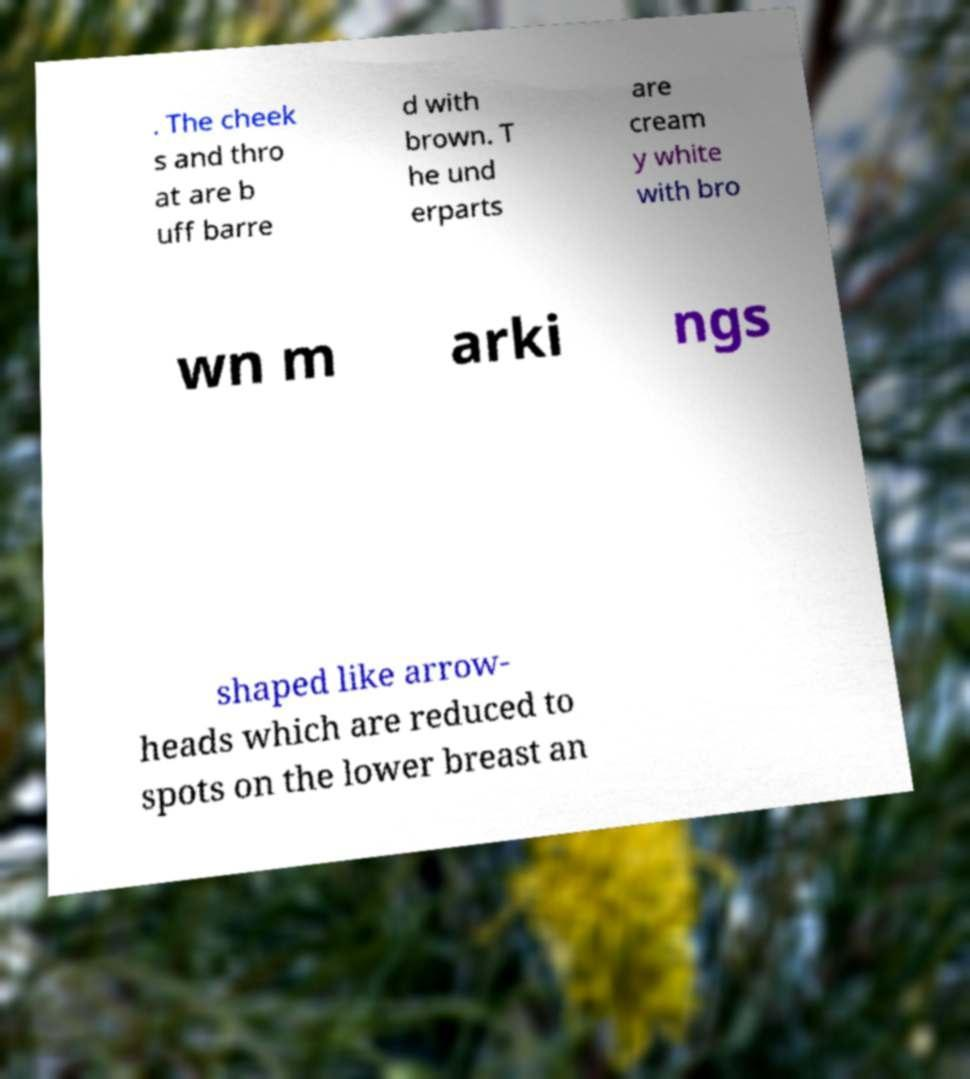Can you accurately transcribe the text from the provided image for me? . The cheek s and thro at are b uff barre d with brown. T he und erparts are cream y white with bro wn m arki ngs shaped like arrow- heads which are reduced to spots on the lower breast an 